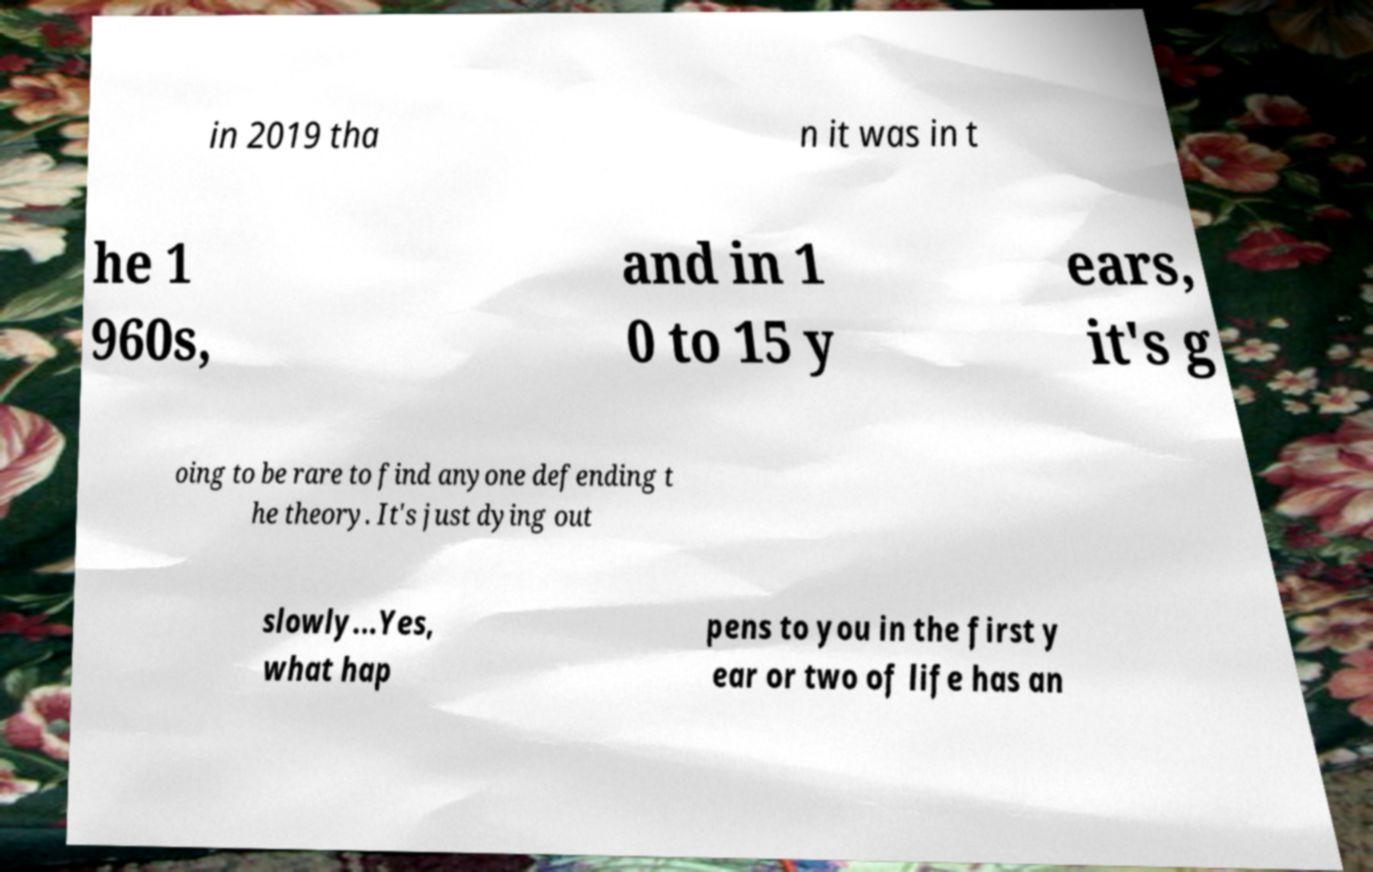Please read and relay the text visible in this image. What does it say? in 2019 tha n it was in t he 1 960s, and in 1 0 to 15 y ears, it's g oing to be rare to find anyone defending t he theory. It's just dying out slowly...Yes, what hap pens to you in the first y ear or two of life has an 